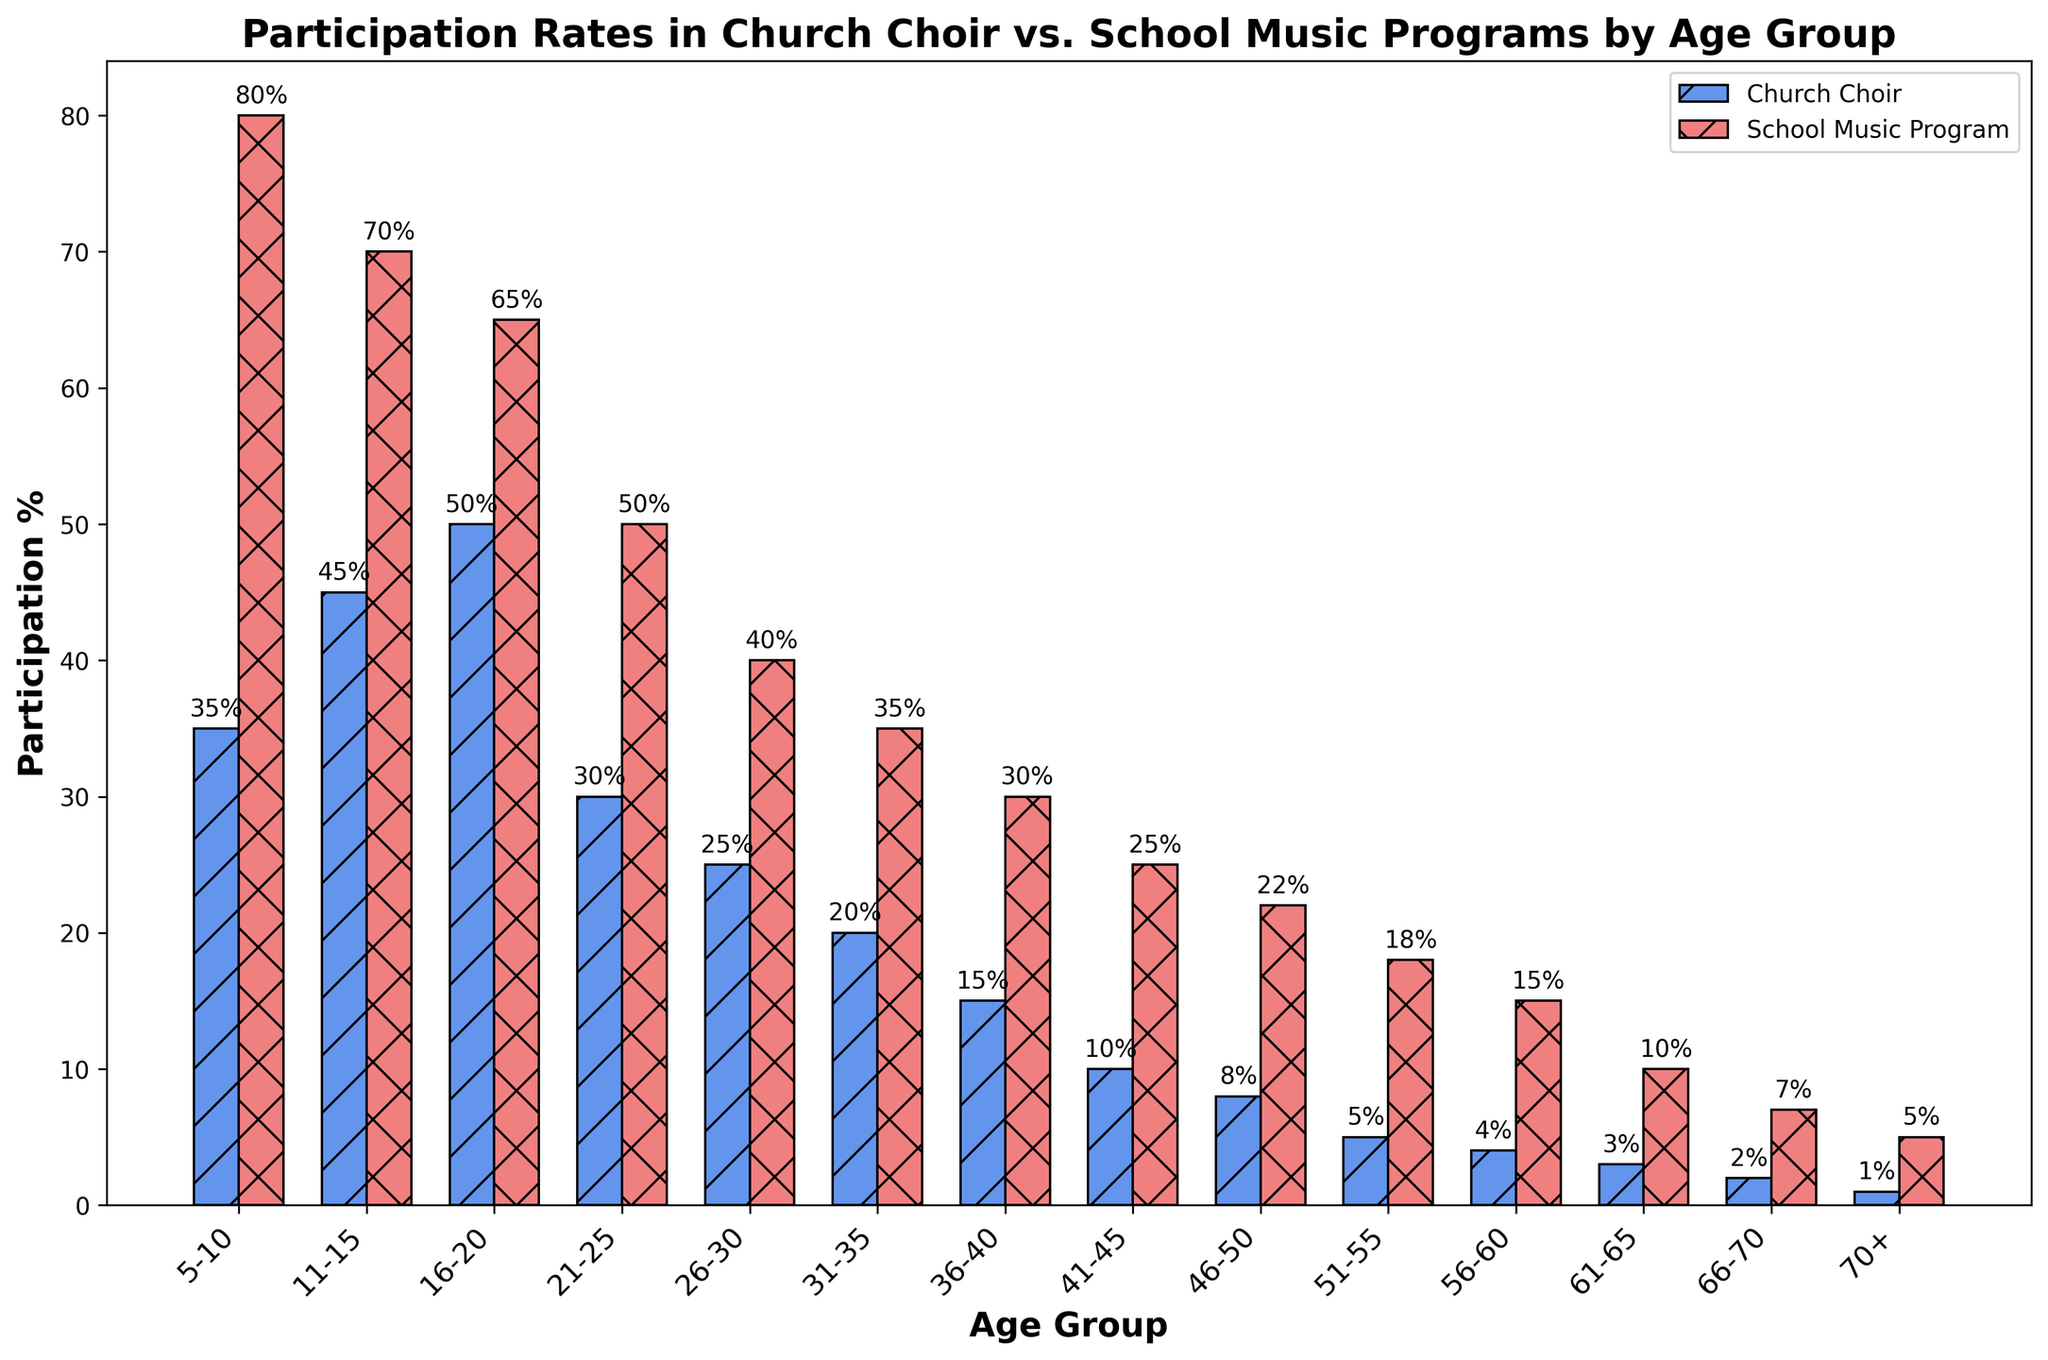What is the participation rate for the 5-10 age group in school music programs? The bar corresponding to the 5-10 age group for school music programs is at the 80% mark.
Answer: 80% Which age group has the highest participation in church choir? The bar for the 16-20 age group for church choirs is the tallest, indicating the highest participation rate of 50%.
Answer: 16-20 At what age does participation in church choir start to decline below 30%? The bar for the 26-30 age group in church choir participation drops to 25%, which is below 30%.
Answer: 26-30 What is the difference in participation rates between the 11-15 age group and the 21-25 age group in school music programs? The participation rate for the 11-15 age group is 70%, and for the 21-25 age group is 50%. The difference is 70% - 50% = 20%.
Answer: 20% How many age groups have a higher participation rate in school music programs than church choirs? Comparing the two sets of bars, all age groups have higher participation rates in school music programs than church choirs. There are 14 age groups in total.
Answer: 14 Which age group shows the smallest difference in participation rates between church choir and school music programs? The 66-70 age group has church choir participation at 2% and school music program participation at 7%, a difference of 5%, which is the smallest among the groups.
Answer: 66-70 What visual feature makes it easy to distinguish between church choir and school music participation rates in the plots? The church choir bars are colored in cornflower blue with a diagonal hatch, while the school music program bars are colored in light coral with an 'x' hatch, making them visually distinct.
Answer: Color and hatching Which age group has the lowest participation in church choirs? The bar for the 70+ age group in church choir participation is the shortest at 1%.
Answer: 70+ If you combine the participation rates for the 26-30 and 31-35 age groups in church choirs, what would be the total participation percentage? The participation rates for 26-30 and 31-35 age groups are 25% and 20%, respectively. Adding these gives 25% + 20% = 45%.
Answer: 45% How does the participation rate for the 61-65 age group in school music programs compare to the 41-45 age group in church choirs? The 61-65 age group in school music programs has a participation rate of 10%, while the 41-45 age group in church choirs has a participation rate of 10%. Both rates are the same.
Answer: Equal 